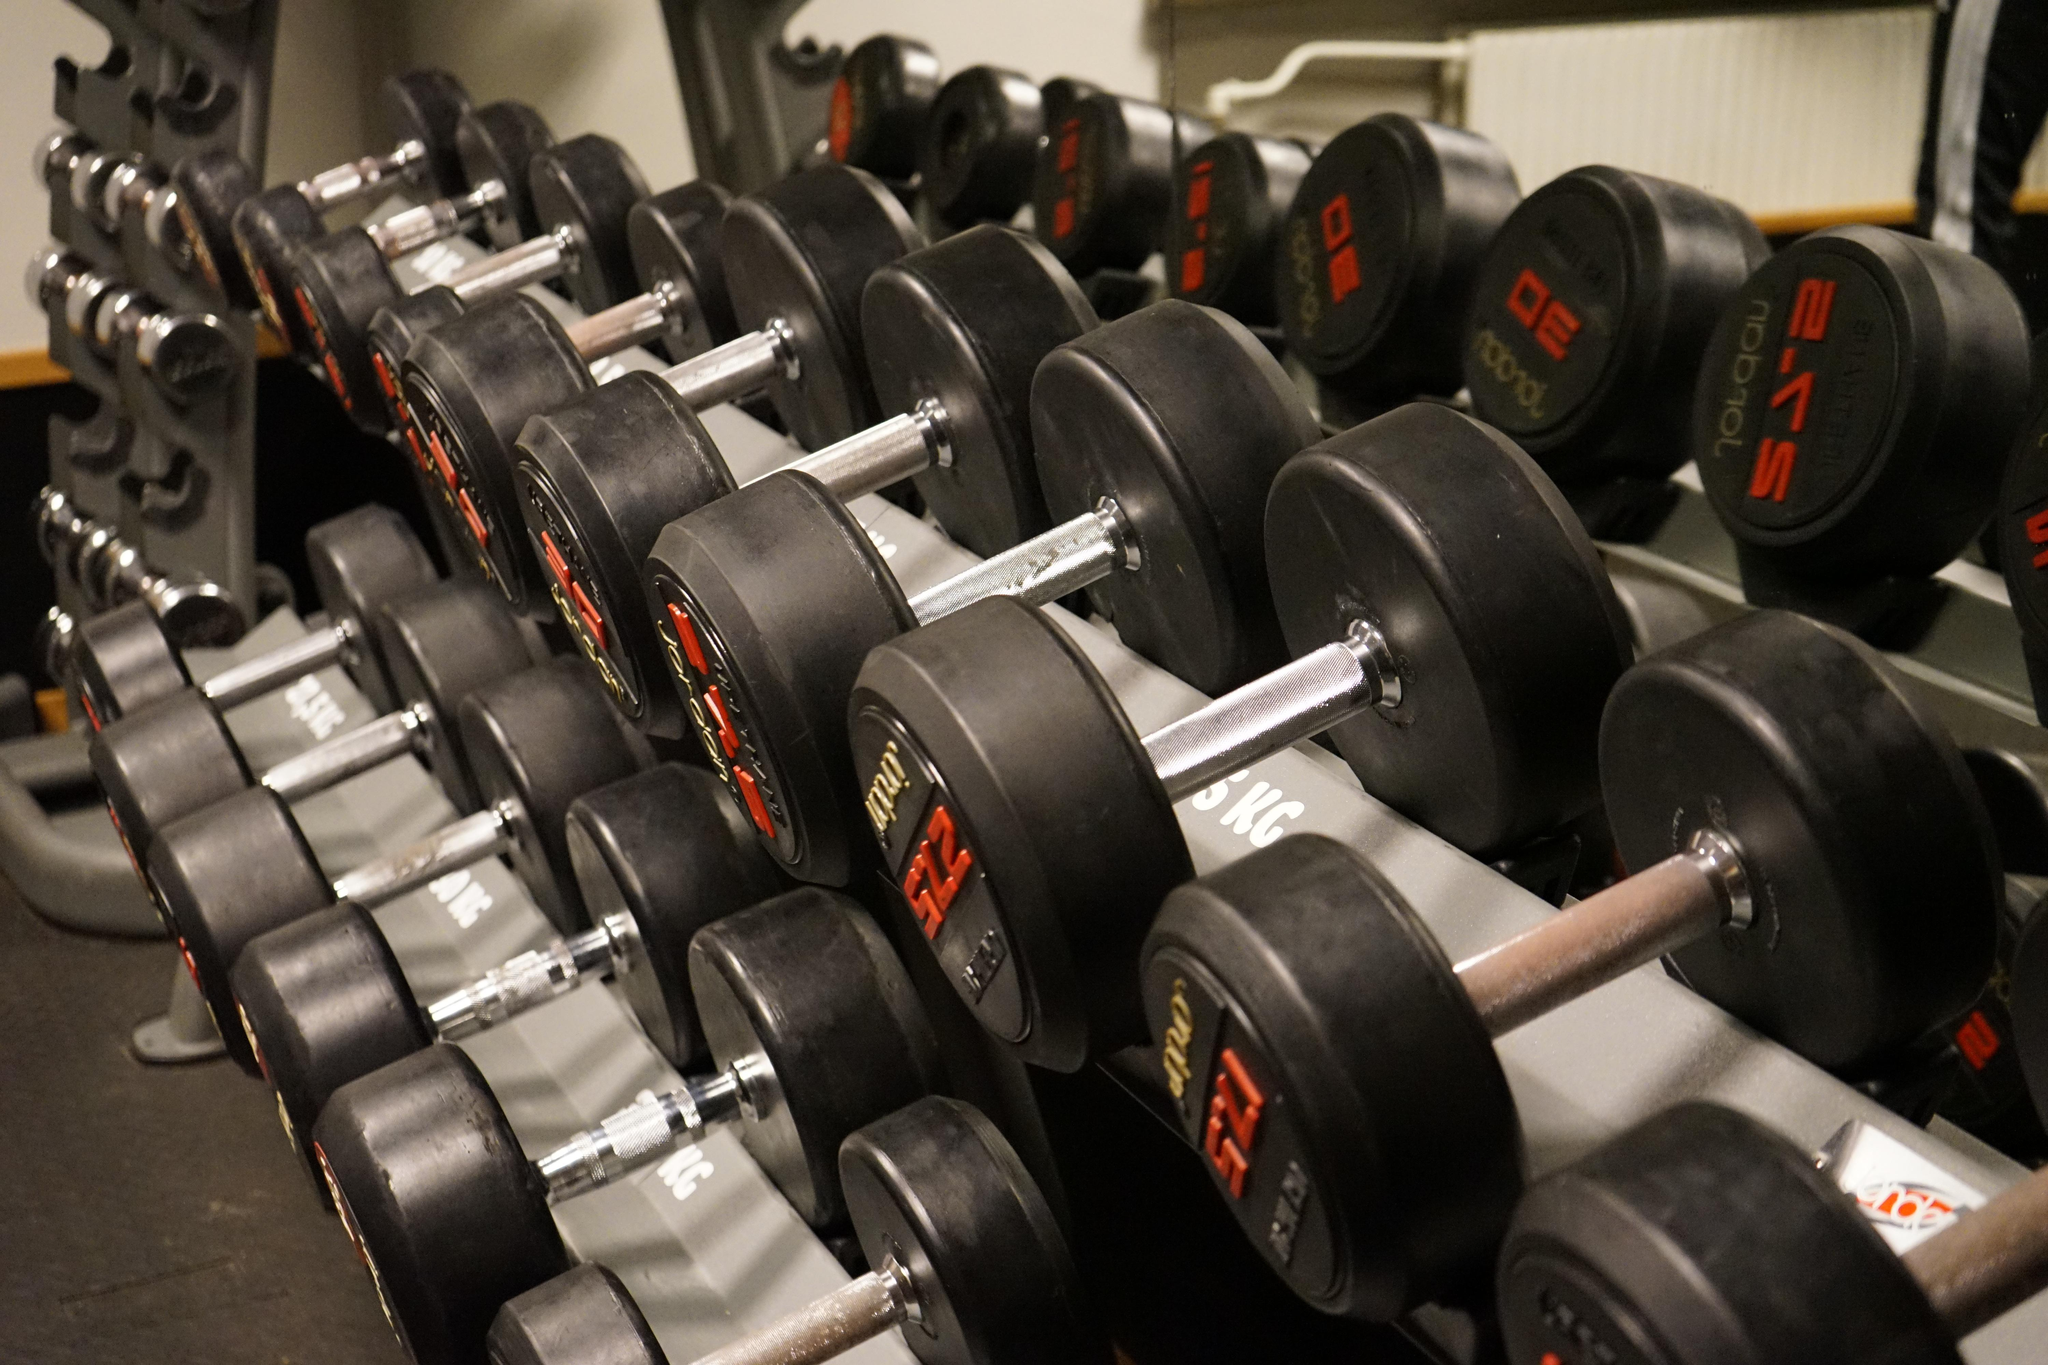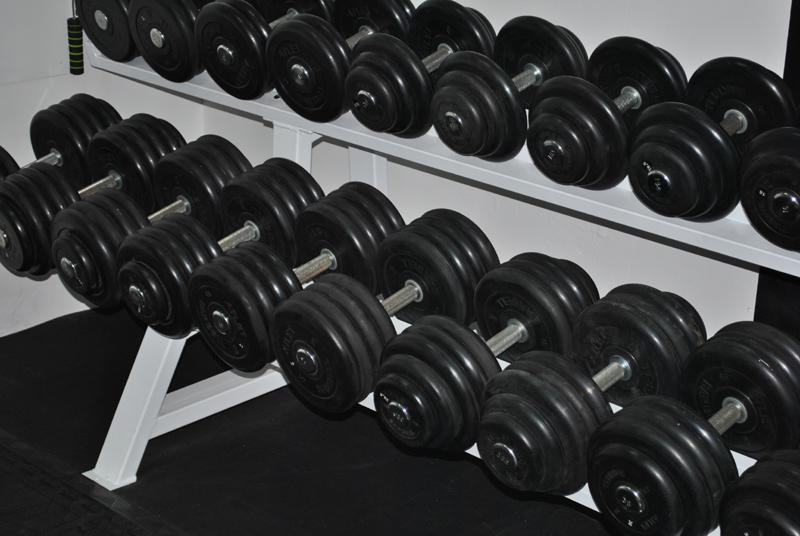The first image is the image on the left, the second image is the image on the right. Analyze the images presented: Is the assertion "One image shows a rack with two angled rows of black dumbbells, and the other image shows a gym with workout equipment and a gray floor." valid? Answer yes or no. No. The first image is the image on the left, the second image is the image on the right. For the images shown, is this caption "In at least one image there is a total of two racks of black weights." true? Answer yes or no. Yes. 